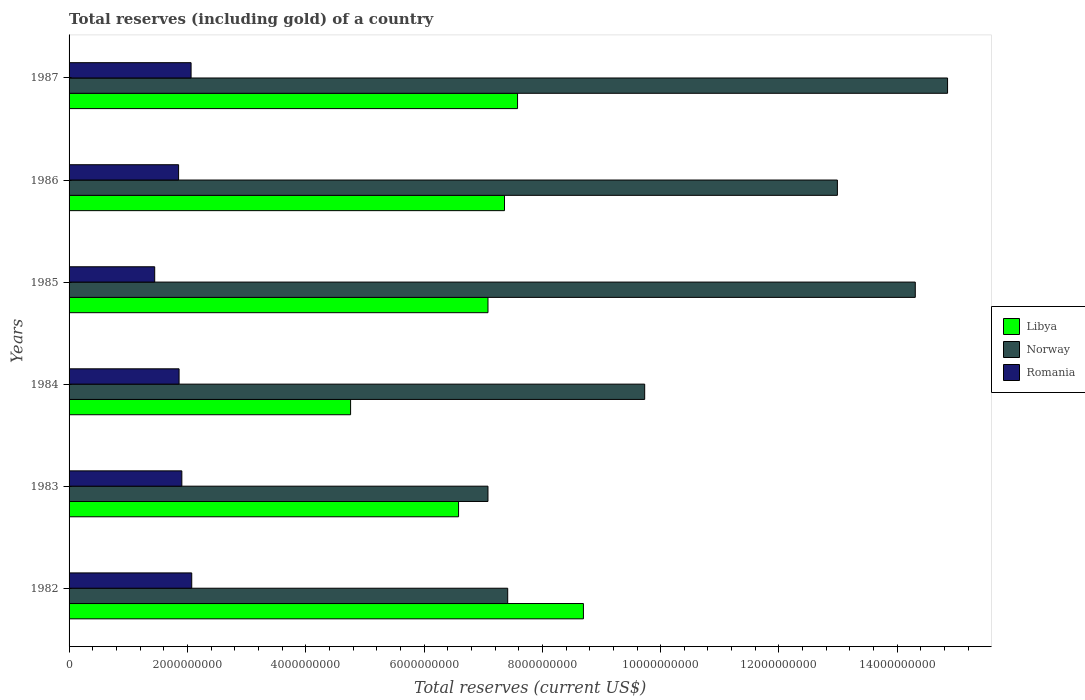How many different coloured bars are there?
Make the answer very short. 3. How many groups of bars are there?
Your answer should be very brief. 6. Are the number of bars per tick equal to the number of legend labels?
Offer a terse response. Yes. Are the number of bars on each tick of the Y-axis equal?
Keep it short and to the point. Yes. How many bars are there on the 3rd tick from the bottom?
Provide a succinct answer. 3. What is the total reserves (including gold) in Libya in 1987?
Provide a succinct answer. 7.58e+09. Across all years, what is the maximum total reserves (including gold) in Romania?
Keep it short and to the point. 2.07e+09. Across all years, what is the minimum total reserves (including gold) in Romania?
Provide a succinct answer. 1.45e+09. In which year was the total reserves (including gold) in Romania minimum?
Give a very brief answer. 1985. What is the total total reserves (including gold) in Norway in the graph?
Make the answer very short. 6.64e+1. What is the difference between the total reserves (including gold) in Romania in 1982 and that in 1985?
Provide a succinct answer. 6.26e+08. What is the difference between the total reserves (including gold) in Romania in 1985 and the total reserves (including gold) in Norway in 1986?
Your answer should be very brief. -1.15e+1. What is the average total reserves (including gold) in Romania per year?
Keep it short and to the point. 1.87e+09. In the year 1985, what is the difference between the total reserves (including gold) in Romania and total reserves (including gold) in Norway?
Keep it short and to the point. -1.29e+1. What is the ratio of the total reserves (including gold) in Libya in 1983 to that in 1985?
Give a very brief answer. 0.93. Is the total reserves (including gold) in Libya in 1985 less than that in 1986?
Make the answer very short. Yes. Is the difference between the total reserves (including gold) in Romania in 1982 and 1985 greater than the difference between the total reserves (including gold) in Norway in 1982 and 1985?
Provide a succinct answer. Yes. What is the difference between the highest and the second highest total reserves (including gold) in Norway?
Offer a terse response. 5.46e+08. What is the difference between the highest and the lowest total reserves (including gold) in Romania?
Provide a succinct answer. 6.26e+08. Is the sum of the total reserves (including gold) in Libya in 1982 and 1987 greater than the maximum total reserves (including gold) in Romania across all years?
Your response must be concise. Yes. What does the 1st bar from the bottom in 1987 represents?
Make the answer very short. Libya. How many bars are there?
Offer a terse response. 18. How many years are there in the graph?
Your response must be concise. 6. Are the values on the major ticks of X-axis written in scientific E-notation?
Give a very brief answer. No. Does the graph contain any zero values?
Offer a terse response. No. How many legend labels are there?
Provide a short and direct response. 3. What is the title of the graph?
Your answer should be very brief. Total reserves (including gold) of a country. Does "Ghana" appear as one of the legend labels in the graph?
Offer a very short reply. No. What is the label or title of the X-axis?
Offer a very short reply. Total reserves (current US$). What is the Total reserves (current US$) of Libya in 1982?
Keep it short and to the point. 8.69e+09. What is the Total reserves (current US$) in Norway in 1982?
Your answer should be compact. 7.41e+09. What is the Total reserves (current US$) in Romania in 1982?
Make the answer very short. 2.07e+09. What is the Total reserves (current US$) in Libya in 1983?
Provide a short and direct response. 6.58e+09. What is the Total reserves (current US$) of Norway in 1983?
Offer a terse response. 7.08e+09. What is the Total reserves (current US$) in Romania in 1983?
Keep it short and to the point. 1.91e+09. What is the Total reserves (current US$) of Libya in 1984?
Offer a very short reply. 4.76e+09. What is the Total reserves (current US$) of Norway in 1984?
Give a very brief answer. 9.73e+09. What is the Total reserves (current US$) in Romania in 1984?
Ensure brevity in your answer.  1.86e+09. What is the Total reserves (current US$) in Libya in 1985?
Keep it short and to the point. 7.08e+09. What is the Total reserves (current US$) in Norway in 1985?
Give a very brief answer. 1.43e+1. What is the Total reserves (current US$) in Romania in 1985?
Your response must be concise. 1.45e+09. What is the Total reserves (current US$) of Libya in 1986?
Make the answer very short. 7.36e+09. What is the Total reserves (current US$) of Norway in 1986?
Provide a succinct answer. 1.30e+1. What is the Total reserves (current US$) of Romania in 1986?
Offer a terse response. 1.85e+09. What is the Total reserves (current US$) in Libya in 1987?
Provide a short and direct response. 7.58e+09. What is the Total reserves (current US$) in Norway in 1987?
Your answer should be compact. 1.48e+1. What is the Total reserves (current US$) in Romania in 1987?
Offer a terse response. 2.06e+09. Across all years, what is the maximum Total reserves (current US$) in Libya?
Make the answer very short. 8.69e+09. Across all years, what is the maximum Total reserves (current US$) of Norway?
Make the answer very short. 1.48e+1. Across all years, what is the maximum Total reserves (current US$) in Romania?
Ensure brevity in your answer.  2.07e+09. Across all years, what is the minimum Total reserves (current US$) in Libya?
Give a very brief answer. 4.76e+09. Across all years, what is the minimum Total reserves (current US$) of Norway?
Make the answer very short. 7.08e+09. Across all years, what is the minimum Total reserves (current US$) of Romania?
Provide a short and direct response. 1.45e+09. What is the total Total reserves (current US$) in Libya in the graph?
Give a very brief answer. 4.21e+1. What is the total Total reserves (current US$) of Norway in the graph?
Your answer should be very brief. 6.64e+1. What is the total Total reserves (current US$) in Romania in the graph?
Provide a short and direct response. 1.12e+1. What is the difference between the Total reserves (current US$) in Libya in 1982 and that in 1983?
Keep it short and to the point. 2.11e+09. What is the difference between the Total reserves (current US$) in Norway in 1982 and that in 1983?
Give a very brief answer. 3.34e+08. What is the difference between the Total reserves (current US$) in Romania in 1982 and that in 1983?
Provide a short and direct response. 1.67e+08. What is the difference between the Total reserves (current US$) of Libya in 1982 and that in 1984?
Your response must be concise. 3.94e+09. What is the difference between the Total reserves (current US$) in Norway in 1982 and that in 1984?
Provide a succinct answer. -2.32e+09. What is the difference between the Total reserves (current US$) in Romania in 1982 and that in 1984?
Offer a very short reply. 2.14e+08. What is the difference between the Total reserves (current US$) of Libya in 1982 and that in 1985?
Offer a very short reply. 1.61e+09. What is the difference between the Total reserves (current US$) in Norway in 1982 and that in 1985?
Give a very brief answer. -6.89e+09. What is the difference between the Total reserves (current US$) of Romania in 1982 and that in 1985?
Keep it short and to the point. 6.26e+08. What is the difference between the Total reserves (current US$) of Libya in 1982 and that in 1986?
Your response must be concise. 1.33e+09. What is the difference between the Total reserves (current US$) of Norway in 1982 and that in 1986?
Keep it short and to the point. -5.57e+09. What is the difference between the Total reserves (current US$) in Romania in 1982 and that in 1986?
Give a very brief answer. 2.22e+08. What is the difference between the Total reserves (current US$) of Libya in 1982 and that in 1987?
Your answer should be very brief. 1.11e+09. What is the difference between the Total reserves (current US$) of Norway in 1982 and that in 1987?
Your answer should be very brief. -7.44e+09. What is the difference between the Total reserves (current US$) of Romania in 1982 and that in 1987?
Keep it short and to the point. 1.10e+07. What is the difference between the Total reserves (current US$) of Libya in 1983 and that in 1984?
Your answer should be very brief. 1.83e+09. What is the difference between the Total reserves (current US$) in Norway in 1983 and that in 1984?
Provide a short and direct response. -2.65e+09. What is the difference between the Total reserves (current US$) of Romania in 1983 and that in 1984?
Offer a terse response. 4.66e+07. What is the difference between the Total reserves (current US$) in Libya in 1983 and that in 1985?
Offer a terse response. -4.97e+08. What is the difference between the Total reserves (current US$) in Norway in 1983 and that in 1985?
Your answer should be very brief. -7.22e+09. What is the difference between the Total reserves (current US$) of Romania in 1983 and that in 1985?
Keep it short and to the point. 4.59e+08. What is the difference between the Total reserves (current US$) of Libya in 1983 and that in 1986?
Your answer should be very brief. -7.77e+08. What is the difference between the Total reserves (current US$) of Norway in 1983 and that in 1986?
Your response must be concise. -5.91e+09. What is the difference between the Total reserves (current US$) of Romania in 1983 and that in 1986?
Provide a short and direct response. 5.48e+07. What is the difference between the Total reserves (current US$) in Libya in 1983 and that in 1987?
Offer a terse response. -9.97e+08. What is the difference between the Total reserves (current US$) of Norway in 1983 and that in 1987?
Your answer should be compact. -7.77e+09. What is the difference between the Total reserves (current US$) of Romania in 1983 and that in 1987?
Keep it short and to the point. -1.56e+08. What is the difference between the Total reserves (current US$) of Libya in 1984 and that in 1985?
Keep it short and to the point. -2.32e+09. What is the difference between the Total reserves (current US$) in Norway in 1984 and that in 1985?
Keep it short and to the point. -4.57e+09. What is the difference between the Total reserves (current US$) of Romania in 1984 and that in 1985?
Offer a terse response. 4.12e+08. What is the difference between the Total reserves (current US$) of Libya in 1984 and that in 1986?
Offer a very short reply. -2.60e+09. What is the difference between the Total reserves (current US$) in Norway in 1984 and that in 1986?
Your answer should be very brief. -3.26e+09. What is the difference between the Total reserves (current US$) in Romania in 1984 and that in 1986?
Keep it short and to the point. 8.17e+06. What is the difference between the Total reserves (current US$) in Libya in 1984 and that in 1987?
Your answer should be very brief. -2.82e+09. What is the difference between the Total reserves (current US$) of Norway in 1984 and that in 1987?
Your response must be concise. -5.12e+09. What is the difference between the Total reserves (current US$) of Romania in 1984 and that in 1987?
Your answer should be very brief. -2.03e+08. What is the difference between the Total reserves (current US$) in Libya in 1985 and that in 1986?
Your answer should be very brief. -2.79e+08. What is the difference between the Total reserves (current US$) in Norway in 1985 and that in 1986?
Ensure brevity in your answer.  1.32e+09. What is the difference between the Total reserves (current US$) of Romania in 1985 and that in 1986?
Your answer should be very brief. -4.04e+08. What is the difference between the Total reserves (current US$) in Libya in 1985 and that in 1987?
Provide a short and direct response. -5.00e+08. What is the difference between the Total reserves (current US$) in Norway in 1985 and that in 1987?
Keep it short and to the point. -5.46e+08. What is the difference between the Total reserves (current US$) in Romania in 1985 and that in 1987?
Your response must be concise. -6.15e+08. What is the difference between the Total reserves (current US$) in Libya in 1986 and that in 1987?
Provide a succinct answer. -2.20e+08. What is the difference between the Total reserves (current US$) of Norway in 1986 and that in 1987?
Your response must be concise. -1.86e+09. What is the difference between the Total reserves (current US$) in Romania in 1986 and that in 1987?
Give a very brief answer. -2.11e+08. What is the difference between the Total reserves (current US$) of Libya in 1982 and the Total reserves (current US$) of Norway in 1983?
Make the answer very short. 1.61e+09. What is the difference between the Total reserves (current US$) of Libya in 1982 and the Total reserves (current US$) of Romania in 1983?
Provide a short and direct response. 6.79e+09. What is the difference between the Total reserves (current US$) of Norway in 1982 and the Total reserves (current US$) of Romania in 1983?
Your answer should be very brief. 5.51e+09. What is the difference between the Total reserves (current US$) of Libya in 1982 and the Total reserves (current US$) of Norway in 1984?
Provide a succinct answer. -1.04e+09. What is the difference between the Total reserves (current US$) in Libya in 1982 and the Total reserves (current US$) in Romania in 1984?
Offer a very short reply. 6.83e+09. What is the difference between the Total reserves (current US$) of Norway in 1982 and the Total reserves (current US$) of Romania in 1984?
Keep it short and to the point. 5.55e+09. What is the difference between the Total reserves (current US$) of Libya in 1982 and the Total reserves (current US$) of Norway in 1985?
Ensure brevity in your answer.  -5.61e+09. What is the difference between the Total reserves (current US$) in Libya in 1982 and the Total reserves (current US$) in Romania in 1985?
Provide a succinct answer. 7.25e+09. What is the difference between the Total reserves (current US$) of Norway in 1982 and the Total reserves (current US$) of Romania in 1985?
Keep it short and to the point. 5.97e+09. What is the difference between the Total reserves (current US$) in Libya in 1982 and the Total reserves (current US$) in Norway in 1986?
Offer a terse response. -4.29e+09. What is the difference between the Total reserves (current US$) in Libya in 1982 and the Total reserves (current US$) in Romania in 1986?
Your response must be concise. 6.84e+09. What is the difference between the Total reserves (current US$) in Norway in 1982 and the Total reserves (current US$) in Romania in 1986?
Ensure brevity in your answer.  5.56e+09. What is the difference between the Total reserves (current US$) of Libya in 1982 and the Total reserves (current US$) of Norway in 1987?
Ensure brevity in your answer.  -6.16e+09. What is the difference between the Total reserves (current US$) in Libya in 1982 and the Total reserves (current US$) in Romania in 1987?
Offer a terse response. 6.63e+09. What is the difference between the Total reserves (current US$) in Norway in 1982 and the Total reserves (current US$) in Romania in 1987?
Make the answer very short. 5.35e+09. What is the difference between the Total reserves (current US$) of Libya in 1983 and the Total reserves (current US$) of Norway in 1984?
Provide a short and direct response. -3.15e+09. What is the difference between the Total reserves (current US$) in Libya in 1983 and the Total reserves (current US$) in Romania in 1984?
Ensure brevity in your answer.  4.72e+09. What is the difference between the Total reserves (current US$) of Norway in 1983 and the Total reserves (current US$) of Romania in 1984?
Provide a succinct answer. 5.22e+09. What is the difference between the Total reserves (current US$) of Libya in 1983 and the Total reserves (current US$) of Norway in 1985?
Make the answer very short. -7.72e+09. What is the difference between the Total reserves (current US$) of Libya in 1983 and the Total reserves (current US$) of Romania in 1985?
Your response must be concise. 5.14e+09. What is the difference between the Total reserves (current US$) of Norway in 1983 and the Total reserves (current US$) of Romania in 1985?
Your answer should be compact. 5.63e+09. What is the difference between the Total reserves (current US$) of Libya in 1983 and the Total reserves (current US$) of Norway in 1986?
Provide a succinct answer. -6.40e+09. What is the difference between the Total reserves (current US$) of Libya in 1983 and the Total reserves (current US$) of Romania in 1986?
Offer a very short reply. 4.73e+09. What is the difference between the Total reserves (current US$) in Norway in 1983 and the Total reserves (current US$) in Romania in 1986?
Offer a terse response. 5.23e+09. What is the difference between the Total reserves (current US$) in Libya in 1983 and the Total reserves (current US$) in Norway in 1987?
Make the answer very short. -8.27e+09. What is the difference between the Total reserves (current US$) of Libya in 1983 and the Total reserves (current US$) of Romania in 1987?
Provide a short and direct response. 4.52e+09. What is the difference between the Total reserves (current US$) in Norway in 1983 and the Total reserves (current US$) in Romania in 1987?
Give a very brief answer. 5.02e+09. What is the difference between the Total reserves (current US$) in Libya in 1984 and the Total reserves (current US$) in Norway in 1985?
Your response must be concise. -9.55e+09. What is the difference between the Total reserves (current US$) in Libya in 1984 and the Total reserves (current US$) in Romania in 1985?
Provide a short and direct response. 3.31e+09. What is the difference between the Total reserves (current US$) of Norway in 1984 and the Total reserves (current US$) of Romania in 1985?
Offer a very short reply. 8.28e+09. What is the difference between the Total reserves (current US$) in Libya in 1984 and the Total reserves (current US$) in Norway in 1986?
Your answer should be very brief. -8.23e+09. What is the difference between the Total reserves (current US$) in Libya in 1984 and the Total reserves (current US$) in Romania in 1986?
Provide a short and direct response. 2.91e+09. What is the difference between the Total reserves (current US$) in Norway in 1984 and the Total reserves (current US$) in Romania in 1986?
Your answer should be compact. 7.88e+09. What is the difference between the Total reserves (current US$) of Libya in 1984 and the Total reserves (current US$) of Norway in 1987?
Provide a succinct answer. -1.01e+1. What is the difference between the Total reserves (current US$) of Libya in 1984 and the Total reserves (current US$) of Romania in 1987?
Your response must be concise. 2.70e+09. What is the difference between the Total reserves (current US$) of Norway in 1984 and the Total reserves (current US$) of Romania in 1987?
Offer a terse response. 7.67e+09. What is the difference between the Total reserves (current US$) in Libya in 1985 and the Total reserves (current US$) in Norway in 1986?
Give a very brief answer. -5.91e+09. What is the difference between the Total reserves (current US$) of Libya in 1985 and the Total reserves (current US$) of Romania in 1986?
Offer a very short reply. 5.23e+09. What is the difference between the Total reserves (current US$) in Norway in 1985 and the Total reserves (current US$) in Romania in 1986?
Offer a terse response. 1.25e+1. What is the difference between the Total reserves (current US$) in Libya in 1985 and the Total reserves (current US$) in Norway in 1987?
Your response must be concise. -7.77e+09. What is the difference between the Total reserves (current US$) in Libya in 1985 and the Total reserves (current US$) in Romania in 1987?
Provide a succinct answer. 5.02e+09. What is the difference between the Total reserves (current US$) of Norway in 1985 and the Total reserves (current US$) of Romania in 1987?
Your response must be concise. 1.22e+1. What is the difference between the Total reserves (current US$) of Libya in 1986 and the Total reserves (current US$) of Norway in 1987?
Keep it short and to the point. -7.49e+09. What is the difference between the Total reserves (current US$) in Libya in 1986 and the Total reserves (current US$) in Romania in 1987?
Your response must be concise. 5.30e+09. What is the difference between the Total reserves (current US$) in Norway in 1986 and the Total reserves (current US$) in Romania in 1987?
Give a very brief answer. 1.09e+1. What is the average Total reserves (current US$) of Libya per year?
Your answer should be compact. 7.01e+09. What is the average Total reserves (current US$) in Norway per year?
Your answer should be compact. 1.11e+1. What is the average Total reserves (current US$) of Romania per year?
Your answer should be very brief. 1.87e+09. In the year 1982, what is the difference between the Total reserves (current US$) in Libya and Total reserves (current US$) in Norway?
Offer a terse response. 1.28e+09. In the year 1982, what is the difference between the Total reserves (current US$) in Libya and Total reserves (current US$) in Romania?
Ensure brevity in your answer.  6.62e+09. In the year 1982, what is the difference between the Total reserves (current US$) in Norway and Total reserves (current US$) in Romania?
Offer a very short reply. 5.34e+09. In the year 1983, what is the difference between the Total reserves (current US$) in Libya and Total reserves (current US$) in Norway?
Your answer should be compact. -4.97e+08. In the year 1983, what is the difference between the Total reserves (current US$) in Libya and Total reserves (current US$) in Romania?
Keep it short and to the point. 4.68e+09. In the year 1983, what is the difference between the Total reserves (current US$) of Norway and Total reserves (current US$) of Romania?
Offer a very short reply. 5.17e+09. In the year 1984, what is the difference between the Total reserves (current US$) of Libya and Total reserves (current US$) of Norway?
Your answer should be compact. -4.97e+09. In the year 1984, what is the difference between the Total reserves (current US$) in Libya and Total reserves (current US$) in Romania?
Your answer should be compact. 2.90e+09. In the year 1984, what is the difference between the Total reserves (current US$) in Norway and Total reserves (current US$) in Romania?
Ensure brevity in your answer.  7.87e+09. In the year 1985, what is the difference between the Total reserves (current US$) of Libya and Total reserves (current US$) of Norway?
Your response must be concise. -7.22e+09. In the year 1985, what is the difference between the Total reserves (current US$) in Libya and Total reserves (current US$) in Romania?
Provide a short and direct response. 5.63e+09. In the year 1985, what is the difference between the Total reserves (current US$) of Norway and Total reserves (current US$) of Romania?
Provide a short and direct response. 1.29e+1. In the year 1986, what is the difference between the Total reserves (current US$) of Libya and Total reserves (current US$) of Norway?
Offer a very short reply. -5.63e+09. In the year 1986, what is the difference between the Total reserves (current US$) in Libya and Total reserves (current US$) in Romania?
Provide a succinct answer. 5.51e+09. In the year 1986, what is the difference between the Total reserves (current US$) of Norway and Total reserves (current US$) of Romania?
Offer a terse response. 1.11e+1. In the year 1987, what is the difference between the Total reserves (current US$) in Libya and Total reserves (current US$) in Norway?
Your answer should be very brief. -7.27e+09. In the year 1987, what is the difference between the Total reserves (current US$) in Libya and Total reserves (current US$) in Romania?
Ensure brevity in your answer.  5.52e+09. In the year 1987, what is the difference between the Total reserves (current US$) in Norway and Total reserves (current US$) in Romania?
Offer a terse response. 1.28e+1. What is the ratio of the Total reserves (current US$) in Libya in 1982 to that in 1983?
Offer a terse response. 1.32. What is the ratio of the Total reserves (current US$) in Norway in 1982 to that in 1983?
Provide a succinct answer. 1.05. What is the ratio of the Total reserves (current US$) of Romania in 1982 to that in 1983?
Ensure brevity in your answer.  1.09. What is the ratio of the Total reserves (current US$) in Libya in 1982 to that in 1984?
Keep it short and to the point. 1.83. What is the ratio of the Total reserves (current US$) of Norway in 1982 to that in 1984?
Provide a short and direct response. 0.76. What is the ratio of the Total reserves (current US$) in Romania in 1982 to that in 1984?
Your response must be concise. 1.11. What is the ratio of the Total reserves (current US$) of Libya in 1982 to that in 1985?
Your response must be concise. 1.23. What is the ratio of the Total reserves (current US$) of Norway in 1982 to that in 1985?
Offer a very short reply. 0.52. What is the ratio of the Total reserves (current US$) in Romania in 1982 to that in 1985?
Provide a short and direct response. 1.43. What is the ratio of the Total reserves (current US$) of Libya in 1982 to that in 1986?
Your answer should be very brief. 1.18. What is the ratio of the Total reserves (current US$) in Norway in 1982 to that in 1986?
Provide a succinct answer. 0.57. What is the ratio of the Total reserves (current US$) in Romania in 1982 to that in 1986?
Provide a succinct answer. 1.12. What is the ratio of the Total reserves (current US$) of Libya in 1982 to that in 1987?
Make the answer very short. 1.15. What is the ratio of the Total reserves (current US$) in Norway in 1982 to that in 1987?
Offer a very short reply. 0.5. What is the ratio of the Total reserves (current US$) of Romania in 1982 to that in 1987?
Provide a succinct answer. 1.01. What is the ratio of the Total reserves (current US$) in Libya in 1983 to that in 1984?
Give a very brief answer. 1.38. What is the ratio of the Total reserves (current US$) of Norway in 1983 to that in 1984?
Your response must be concise. 0.73. What is the ratio of the Total reserves (current US$) of Romania in 1983 to that in 1984?
Offer a very short reply. 1.03. What is the ratio of the Total reserves (current US$) in Libya in 1983 to that in 1985?
Your response must be concise. 0.93. What is the ratio of the Total reserves (current US$) of Norway in 1983 to that in 1985?
Your answer should be very brief. 0.49. What is the ratio of the Total reserves (current US$) in Romania in 1983 to that in 1985?
Keep it short and to the point. 1.32. What is the ratio of the Total reserves (current US$) in Libya in 1983 to that in 1986?
Provide a short and direct response. 0.89. What is the ratio of the Total reserves (current US$) of Norway in 1983 to that in 1986?
Offer a very short reply. 0.55. What is the ratio of the Total reserves (current US$) in Romania in 1983 to that in 1986?
Keep it short and to the point. 1.03. What is the ratio of the Total reserves (current US$) of Libya in 1983 to that in 1987?
Offer a very short reply. 0.87. What is the ratio of the Total reserves (current US$) of Norway in 1983 to that in 1987?
Your answer should be very brief. 0.48. What is the ratio of the Total reserves (current US$) of Romania in 1983 to that in 1987?
Offer a terse response. 0.92. What is the ratio of the Total reserves (current US$) in Libya in 1984 to that in 1985?
Give a very brief answer. 0.67. What is the ratio of the Total reserves (current US$) of Norway in 1984 to that in 1985?
Your answer should be very brief. 0.68. What is the ratio of the Total reserves (current US$) of Romania in 1984 to that in 1985?
Provide a succinct answer. 1.28. What is the ratio of the Total reserves (current US$) of Libya in 1984 to that in 1986?
Your response must be concise. 0.65. What is the ratio of the Total reserves (current US$) in Norway in 1984 to that in 1986?
Your answer should be very brief. 0.75. What is the ratio of the Total reserves (current US$) of Romania in 1984 to that in 1986?
Your answer should be very brief. 1. What is the ratio of the Total reserves (current US$) of Libya in 1984 to that in 1987?
Ensure brevity in your answer.  0.63. What is the ratio of the Total reserves (current US$) of Norway in 1984 to that in 1987?
Your response must be concise. 0.66. What is the ratio of the Total reserves (current US$) in Romania in 1984 to that in 1987?
Your answer should be compact. 0.9. What is the ratio of the Total reserves (current US$) of Libya in 1985 to that in 1986?
Offer a terse response. 0.96. What is the ratio of the Total reserves (current US$) in Norway in 1985 to that in 1986?
Your response must be concise. 1.1. What is the ratio of the Total reserves (current US$) in Romania in 1985 to that in 1986?
Give a very brief answer. 0.78. What is the ratio of the Total reserves (current US$) of Libya in 1985 to that in 1987?
Offer a terse response. 0.93. What is the ratio of the Total reserves (current US$) in Norway in 1985 to that in 1987?
Your response must be concise. 0.96. What is the ratio of the Total reserves (current US$) of Romania in 1985 to that in 1987?
Make the answer very short. 0.7. What is the ratio of the Total reserves (current US$) of Libya in 1986 to that in 1987?
Give a very brief answer. 0.97. What is the ratio of the Total reserves (current US$) in Norway in 1986 to that in 1987?
Provide a succinct answer. 0.87. What is the ratio of the Total reserves (current US$) of Romania in 1986 to that in 1987?
Ensure brevity in your answer.  0.9. What is the difference between the highest and the second highest Total reserves (current US$) in Libya?
Give a very brief answer. 1.11e+09. What is the difference between the highest and the second highest Total reserves (current US$) of Norway?
Make the answer very short. 5.46e+08. What is the difference between the highest and the second highest Total reserves (current US$) of Romania?
Ensure brevity in your answer.  1.10e+07. What is the difference between the highest and the lowest Total reserves (current US$) of Libya?
Keep it short and to the point. 3.94e+09. What is the difference between the highest and the lowest Total reserves (current US$) of Norway?
Give a very brief answer. 7.77e+09. What is the difference between the highest and the lowest Total reserves (current US$) of Romania?
Your answer should be very brief. 6.26e+08. 